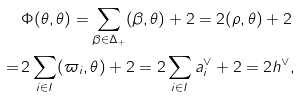Convert formula to latex. <formula><loc_0><loc_0><loc_500><loc_500>& \Phi ( \theta , \theta ) = \sum _ { \beta \in \Delta _ { + } } ( \beta , \theta ) + 2 = 2 ( \rho , \theta ) + 2 \\ = \, & 2 \sum _ { i \in I } ( \varpi _ { i } , \theta ) + 2 = 2 \sum _ { i \in I } a _ { i } ^ { \vee } + 2 = 2 h ^ { \vee } ,</formula> 